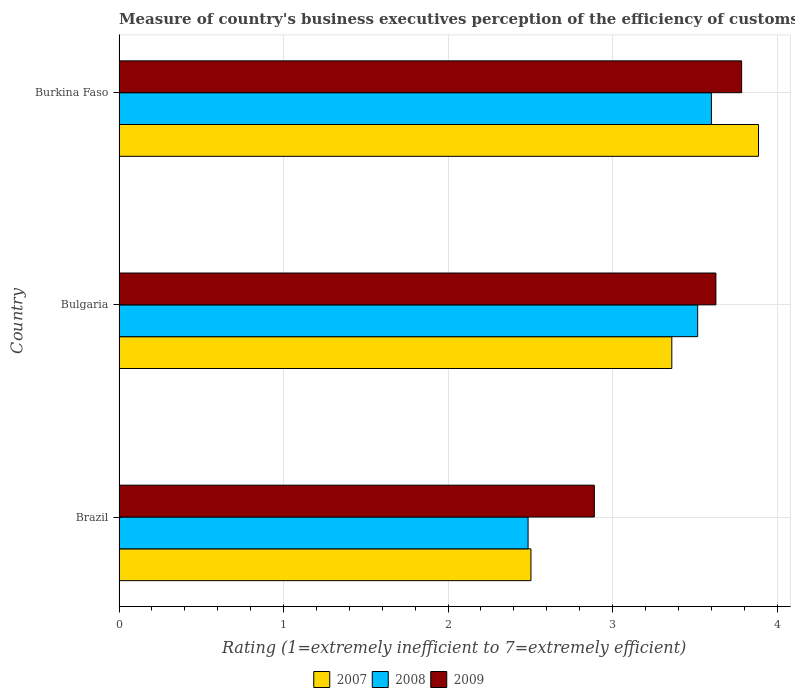How many groups of bars are there?
Your response must be concise. 3. Are the number of bars per tick equal to the number of legend labels?
Offer a very short reply. Yes. What is the label of the 3rd group of bars from the top?
Give a very brief answer. Brazil. In how many cases, is the number of bars for a given country not equal to the number of legend labels?
Provide a short and direct response. 0. What is the rating of the efficiency of customs procedure in 2009 in Bulgaria?
Your response must be concise. 3.63. Across all countries, what is the maximum rating of the efficiency of customs procedure in 2007?
Offer a terse response. 3.89. Across all countries, what is the minimum rating of the efficiency of customs procedure in 2008?
Provide a short and direct response. 2.49. In which country was the rating of the efficiency of customs procedure in 2007 maximum?
Make the answer very short. Burkina Faso. What is the total rating of the efficiency of customs procedure in 2009 in the graph?
Provide a short and direct response. 10.3. What is the difference between the rating of the efficiency of customs procedure in 2008 in Bulgaria and that in Burkina Faso?
Give a very brief answer. -0.08. What is the difference between the rating of the efficiency of customs procedure in 2007 in Burkina Faso and the rating of the efficiency of customs procedure in 2009 in Bulgaria?
Ensure brevity in your answer.  0.26. What is the average rating of the efficiency of customs procedure in 2008 per country?
Your response must be concise. 3.2. What is the difference between the rating of the efficiency of customs procedure in 2009 and rating of the efficiency of customs procedure in 2008 in Bulgaria?
Make the answer very short. 0.11. In how many countries, is the rating of the efficiency of customs procedure in 2007 greater than 1.8 ?
Provide a short and direct response. 3. What is the ratio of the rating of the efficiency of customs procedure in 2007 in Bulgaria to that in Burkina Faso?
Your answer should be very brief. 0.86. What is the difference between the highest and the second highest rating of the efficiency of customs procedure in 2007?
Ensure brevity in your answer.  0.53. What is the difference between the highest and the lowest rating of the efficiency of customs procedure in 2008?
Your answer should be very brief. 1.11. Is the sum of the rating of the efficiency of customs procedure in 2007 in Brazil and Bulgaria greater than the maximum rating of the efficiency of customs procedure in 2008 across all countries?
Your answer should be very brief. Yes. What does the 2nd bar from the top in Burkina Faso represents?
Your answer should be very brief. 2008. What does the 1st bar from the bottom in Bulgaria represents?
Offer a very short reply. 2007. Is it the case that in every country, the sum of the rating of the efficiency of customs procedure in 2007 and rating of the efficiency of customs procedure in 2009 is greater than the rating of the efficiency of customs procedure in 2008?
Make the answer very short. Yes. Are all the bars in the graph horizontal?
Keep it short and to the point. Yes. What is the difference between two consecutive major ticks on the X-axis?
Offer a very short reply. 1. How many legend labels are there?
Provide a short and direct response. 3. What is the title of the graph?
Offer a very short reply. Measure of country's business executives perception of the efficiency of customs procedures. What is the label or title of the X-axis?
Provide a succinct answer. Rating (1=extremely inefficient to 7=extremely efficient). What is the label or title of the Y-axis?
Give a very brief answer. Country. What is the Rating (1=extremely inefficient to 7=extremely efficient) in 2007 in Brazil?
Your answer should be compact. 2.5. What is the Rating (1=extremely inefficient to 7=extremely efficient) of 2008 in Brazil?
Give a very brief answer. 2.49. What is the Rating (1=extremely inefficient to 7=extremely efficient) in 2009 in Brazil?
Make the answer very short. 2.89. What is the Rating (1=extremely inefficient to 7=extremely efficient) of 2007 in Bulgaria?
Make the answer very short. 3.36. What is the Rating (1=extremely inefficient to 7=extremely efficient) of 2008 in Bulgaria?
Provide a short and direct response. 3.52. What is the Rating (1=extremely inefficient to 7=extremely efficient) of 2009 in Bulgaria?
Your answer should be compact. 3.63. What is the Rating (1=extremely inefficient to 7=extremely efficient) of 2007 in Burkina Faso?
Provide a succinct answer. 3.89. What is the Rating (1=extremely inefficient to 7=extremely efficient) of 2008 in Burkina Faso?
Give a very brief answer. 3.6. What is the Rating (1=extremely inefficient to 7=extremely efficient) in 2009 in Burkina Faso?
Your response must be concise. 3.78. Across all countries, what is the maximum Rating (1=extremely inefficient to 7=extremely efficient) of 2007?
Offer a very short reply. 3.89. Across all countries, what is the maximum Rating (1=extremely inefficient to 7=extremely efficient) of 2008?
Provide a short and direct response. 3.6. Across all countries, what is the maximum Rating (1=extremely inefficient to 7=extremely efficient) of 2009?
Offer a very short reply. 3.78. Across all countries, what is the minimum Rating (1=extremely inefficient to 7=extremely efficient) of 2007?
Your answer should be very brief. 2.5. Across all countries, what is the minimum Rating (1=extremely inefficient to 7=extremely efficient) of 2008?
Keep it short and to the point. 2.49. Across all countries, what is the minimum Rating (1=extremely inefficient to 7=extremely efficient) in 2009?
Offer a terse response. 2.89. What is the total Rating (1=extremely inefficient to 7=extremely efficient) in 2007 in the graph?
Your response must be concise. 9.75. What is the total Rating (1=extremely inefficient to 7=extremely efficient) in 2008 in the graph?
Provide a succinct answer. 9.6. What is the total Rating (1=extremely inefficient to 7=extremely efficient) in 2009 in the graph?
Your response must be concise. 10.3. What is the difference between the Rating (1=extremely inefficient to 7=extremely efficient) in 2007 in Brazil and that in Bulgaria?
Provide a short and direct response. -0.86. What is the difference between the Rating (1=extremely inefficient to 7=extremely efficient) of 2008 in Brazil and that in Bulgaria?
Provide a succinct answer. -1.03. What is the difference between the Rating (1=extremely inefficient to 7=extremely efficient) of 2009 in Brazil and that in Bulgaria?
Keep it short and to the point. -0.74. What is the difference between the Rating (1=extremely inefficient to 7=extremely efficient) of 2007 in Brazil and that in Burkina Faso?
Make the answer very short. -1.38. What is the difference between the Rating (1=extremely inefficient to 7=extremely efficient) in 2008 in Brazil and that in Burkina Faso?
Your response must be concise. -1.11. What is the difference between the Rating (1=extremely inefficient to 7=extremely efficient) of 2009 in Brazil and that in Burkina Faso?
Offer a very short reply. -0.9. What is the difference between the Rating (1=extremely inefficient to 7=extremely efficient) of 2007 in Bulgaria and that in Burkina Faso?
Your answer should be very brief. -0.53. What is the difference between the Rating (1=extremely inefficient to 7=extremely efficient) in 2008 in Bulgaria and that in Burkina Faso?
Your answer should be very brief. -0.08. What is the difference between the Rating (1=extremely inefficient to 7=extremely efficient) in 2009 in Bulgaria and that in Burkina Faso?
Offer a terse response. -0.16. What is the difference between the Rating (1=extremely inefficient to 7=extremely efficient) of 2007 in Brazil and the Rating (1=extremely inefficient to 7=extremely efficient) of 2008 in Bulgaria?
Provide a short and direct response. -1.01. What is the difference between the Rating (1=extremely inefficient to 7=extremely efficient) of 2007 in Brazil and the Rating (1=extremely inefficient to 7=extremely efficient) of 2009 in Bulgaria?
Offer a very short reply. -1.12. What is the difference between the Rating (1=extremely inefficient to 7=extremely efficient) of 2008 in Brazil and the Rating (1=extremely inefficient to 7=extremely efficient) of 2009 in Bulgaria?
Your answer should be very brief. -1.14. What is the difference between the Rating (1=extremely inefficient to 7=extremely efficient) in 2007 in Brazil and the Rating (1=extremely inefficient to 7=extremely efficient) in 2008 in Burkina Faso?
Offer a terse response. -1.1. What is the difference between the Rating (1=extremely inefficient to 7=extremely efficient) of 2007 in Brazil and the Rating (1=extremely inefficient to 7=extremely efficient) of 2009 in Burkina Faso?
Offer a very short reply. -1.28. What is the difference between the Rating (1=extremely inefficient to 7=extremely efficient) in 2008 in Brazil and the Rating (1=extremely inefficient to 7=extremely efficient) in 2009 in Burkina Faso?
Your answer should be very brief. -1.3. What is the difference between the Rating (1=extremely inefficient to 7=extremely efficient) in 2007 in Bulgaria and the Rating (1=extremely inefficient to 7=extremely efficient) in 2008 in Burkina Faso?
Your answer should be very brief. -0.24. What is the difference between the Rating (1=extremely inefficient to 7=extremely efficient) in 2007 in Bulgaria and the Rating (1=extremely inefficient to 7=extremely efficient) in 2009 in Burkina Faso?
Make the answer very short. -0.42. What is the difference between the Rating (1=extremely inefficient to 7=extremely efficient) in 2008 in Bulgaria and the Rating (1=extremely inefficient to 7=extremely efficient) in 2009 in Burkina Faso?
Offer a terse response. -0.27. What is the average Rating (1=extremely inefficient to 7=extremely efficient) of 2007 per country?
Offer a very short reply. 3.25. What is the average Rating (1=extremely inefficient to 7=extremely efficient) of 2008 per country?
Provide a succinct answer. 3.2. What is the average Rating (1=extremely inefficient to 7=extremely efficient) of 2009 per country?
Your response must be concise. 3.43. What is the difference between the Rating (1=extremely inefficient to 7=extremely efficient) in 2007 and Rating (1=extremely inefficient to 7=extremely efficient) in 2008 in Brazil?
Your answer should be compact. 0.02. What is the difference between the Rating (1=extremely inefficient to 7=extremely efficient) in 2007 and Rating (1=extremely inefficient to 7=extremely efficient) in 2009 in Brazil?
Offer a terse response. -0.39. What is the difference between the Rating (1=extremely inefficient to 7=extremely efficient) in 2008 and Rating (1=extremely inefficient to 7=extremely efficient) in 2009 in Brazil?
Ensure brevity in your answer.  -0.4. What is the difference between the Rating (1=extremely inefficient to 7=extremely efficient) of 2007 and Rating (1=extremely inefficient to 7=extremely efficient) of 2008 in Bulgaria?
Your answer should be compact. -0.16. What is the difference between the Rating (1=extremely inefficient to 7=extremely efficient) in 2007 and Rating (1=extremely inefficient to 7=extremely efficient) in 2009 in Bulgaria?
Your answer should be compact. -0.27. What is the difference between the Rating (1=extremely inefficient to 7=extremely efficient) in 2008 and Rating (1=extremely inefficient to 7=extremely efficient) in 2009 in Bulgaria?
Ensure brevity in your answer.  -0.11. What is the difference between the Rating (1=extremely inefficient to 7=extremely efficient) in 2007 and Rating (1=extremely inefficient to 7=extremely efficient) in 2008 in Burkina Faso?
Your answer should be compact. 0.29. What is the difference between the Rating (1=extremely inefficient to 7=extremely efficient) of 2007 and Rating (1=extremely inefficient to 7=extremely efficient) of 2009 in Burkina Faso?
Provide a succinct answer. 0.1. What is the difference between the Rating (1=extremely inefficient to 7=extremely efficient) of 2008 and Rating (1=extremely inefficient to 7=extremely efficient) of 2009 in Burkina Faso?
Offer a terse response. -0.18. What is the ratio of the Rating (1=extremely inefficient to 7=extremely efficient) of 2007 in Brazil to that in Bulgaria?
Your answer should be compact. 0.75. What is the ratio of the Rating (1=extremely inefficient to 7=extremely efficient) of 2008 in Brazil to that in Bulgaria?
Make the answer very short. 0.71. What is the ratio of the Rating (1=extremely inefficient to 7=extremely efficient) in 2009 in Brazil to that in Bulgaria?
Provide a short and direct response. 0.8. What is the ratio of the Rating (1=extremely inefficient to 7=extremely efficient) of 2007 in Brazil to that in Burkina Faso?
Your answer should be very brief. 0.64. What is the ratio of the Rating (1=extremely inefficient to 7=extremely efficient) of 2008 in Brazil to that in Burkina Faso?
Ensure brevity in your answer.  0.69. What is the ratio of the Rating (1=extremely inefficient to 7=extremely efficient) in 2009 in Brazil to that in Burkina Faso?
Offer a terse response. 0.76. What is the ratio of the Rating (1=extremely inefficient to 7=extremely efficient) in 2007 in Bulgaria to that in Burkina Faso?
Provide a succinct answer. 0.86. What is the ratio of the Rating (1=extremely inefficient to 7=extremely efficient) of 2008 in Bulgaria to that in Burkina Faso?
Your answer should be compact. 0.98. What is the ratio of the Rating (1=extremely inefficient to 7=extremely efficient) of 2009 in Bulgaria to that in Burkina Faso?
Ensure brevity in your answer.  0.96. What is the difference between the highest and the second highest Rating (1=extremely inefficient to 7=extremely efficient) in 2007?
Provide a succinct answer. 0.53. What is the difference between the highest and the second highest Rating (1=extremely inefficient to 7=extremely efficient) in 2008?
Offer a terse response. 0.08. What is the difference between the highest and the second highest Rating (1=extremely inefficient to 7=extremely efficient) in 2009?
Your answer should be very brief. 0.16. What is the difference between the highest and the lowest Rating (1=extremely inefficient to 7=extremely efficient) in 2007?
Provide a succinct answer. 1.38. What is the difference between the highest and the lowest Rating (1=extremely inefficient to 7=extremely efficient) of 2008?
Keep it short and to the point. 1.11. What is the difference between the highest and the lowest Rating (1=extremely inefficient to 7=extremely efficient) of 2009?
Your answer should be very brief. 0.9. 